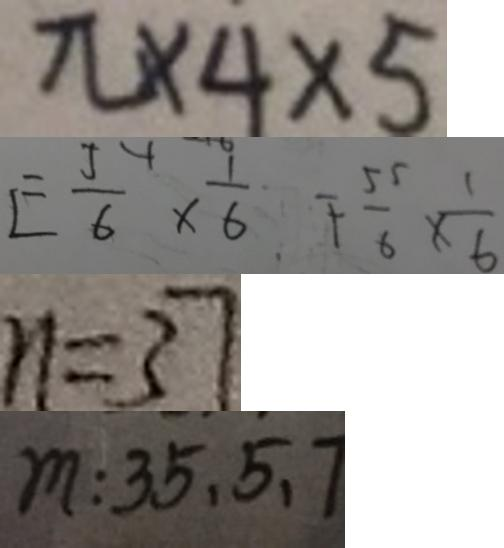Convert formula to latex. <formula><loc_0><loc_0><loc_500><loc_500>\pi \times 4 \times 5 
 E \frac { 5 } { 6 } \times \frac { 1 } { 6 } F \frac { 5 5 } { 6 } \times \frac { 1 } { 6 } 
 n = 3 7 
 m : 3 5 , 5 , 7</formula> 